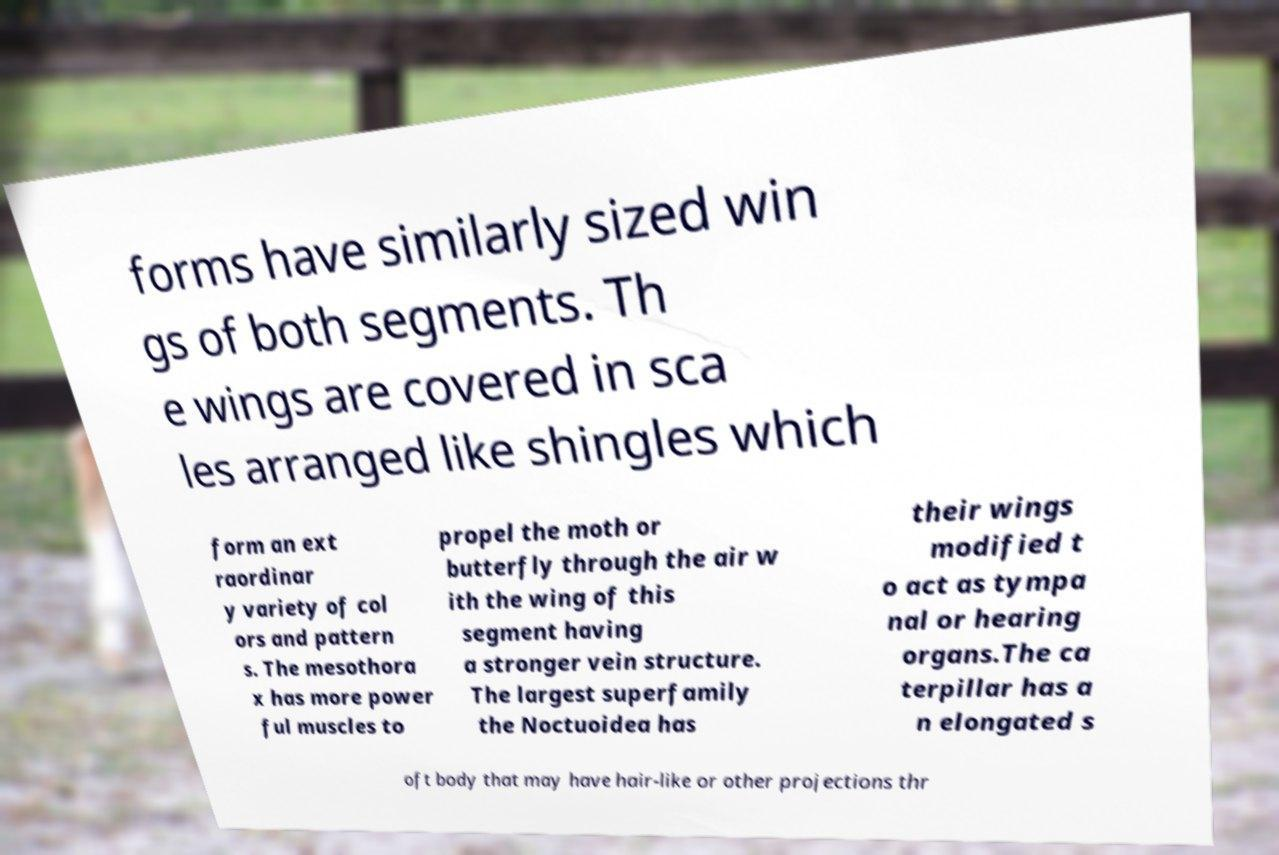There's text embedded in this image that I need extracted. Can you transcribe it verbatim? forms have similarly sized win gs of both segments. Th e wings are covered in sca les arranged like shingles which form an ext raordinar y variety of col ors and pattern s. The mesothora x has more power ful muscles to propel the moth or butterfly through the air w ith the wing of this segment having a stronger vein structure. The largest superfamily the Noctuoidea has their wings modified t o act as tympa nal or hearing organs.The ca terpillar has a n elongated s oft body that may have hair-like or other projections thr 